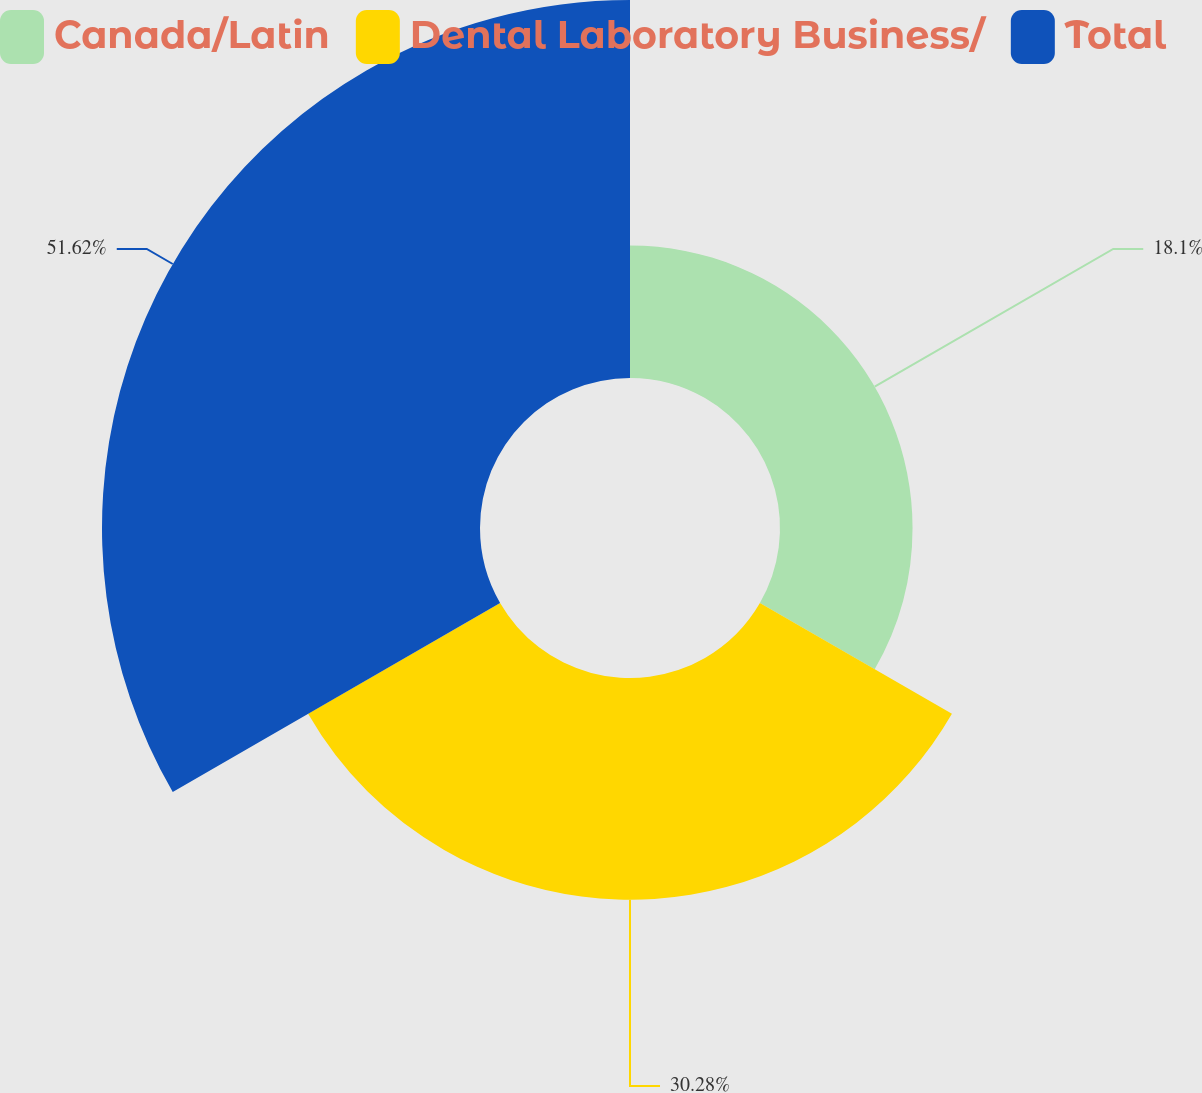Convert chart. <chart><loc_0><loc_0><loc_500><loc_500><pie_chart><fcel>Canada/Latin<fcel>Dental Laboratory Business/<fcel>Total<nl><fcel>18.1%<fcel>30.28%<fcel>51.62%<nl></chart> 